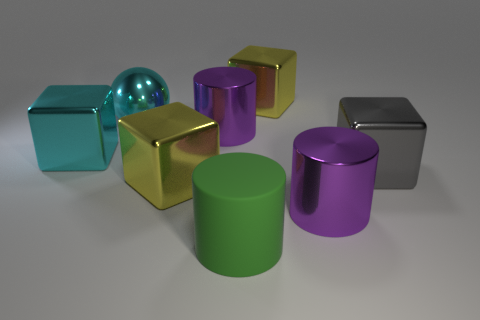What color is the metallic sphere?
Ensure brevity in your answer.  Cyan. What is the material of the large block that is to the left of the large rubber cylinder and to the right of the sphere?
Keep it short and to the point. Metal. There is a large metal thing on the right side of the purple thing to the right of the green rubber cylinder; is there a big purple object that is right of it?
Your answer should be very brief. No. What is the size of the metallic cube that is the same color as the big sphere?
Provide a short and direct response. Large. Are there any green rubber cylinders behind the large shiny sphere?
Your answer should be very brief. No. What number of other things are the same shape as the gray metal thing?
Your response must be concise. 3. What color is the metallic sphere that is the same size as the green rubber object?
Offer a very short reply. Cyan. Are there fewer cyan metallic things that are behind the big cyan ball than large yellow objects that are in front of the big rubber cylinder?
Provide a succinct answer. No. There is a big metallic object to the right of the large purple cylinder that is in front of the big gray metallic cube; what number of cyan things are in front of it?
Offer a very short reply. 0. The cyan metallic thing that is the same shape as the large gray metallic thing is what size?
Your answer should be very brief. Large. 